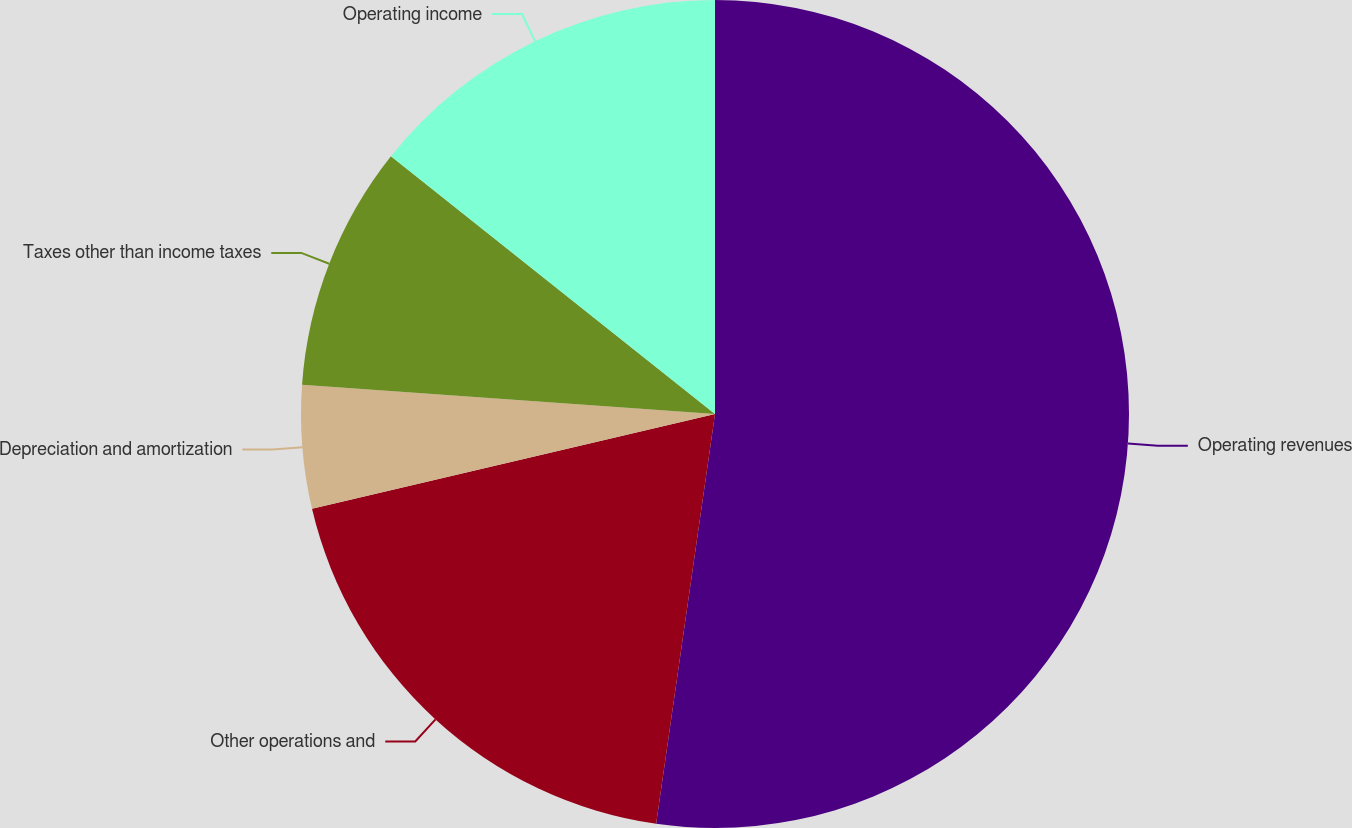<chart> <loc_0><loc_0><loc_500><loc_500><pie_chart><fcel>Operating revenues<fcel>Other operations and<fcel>Depreciation and amortization<fcel>Taxes other than income taxes<fcel>Operating income<nl><fcel>52.27%<fcel>19.05%<fcel>4.81%<fcel>9.56%<fcel>14.31%<nl></chart> 